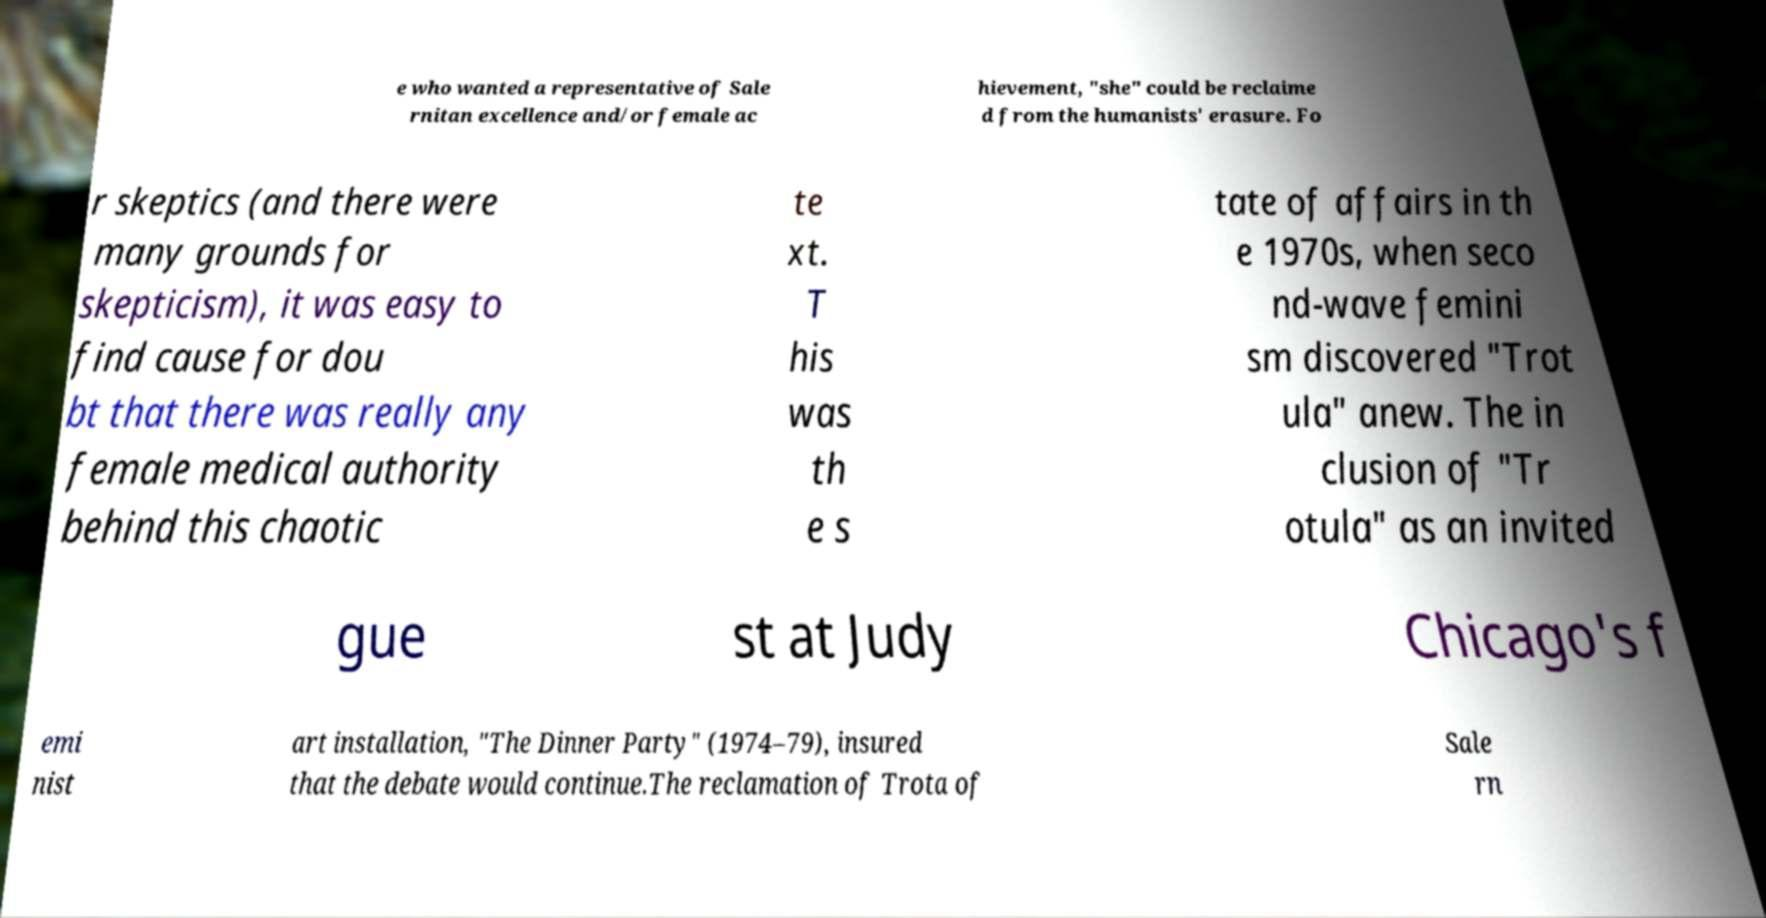Please read and relay the text visible in this image. What does it say? e who wanted a representative of Sale rnitan excellence and/or female ac hievement, "she" could be reclaime d from the humanists' erasure. Fo r skeptics (and there were many grounds for skepticism), it was easy to find cause for dou bt that there was really any female medical authority behind this chaotic te xt. T his was th e s tate of affairs in th e 1970s, when seco nd-wave femini sm discovered "Trot ula" anew. The in clusion of "Tr otula" as an invited gue st at Judy Chicago's f emi nist art installation, "The Dinner Party" (1974–79), insured that the debate would continue.The reclamation of Trota of Sale rn 